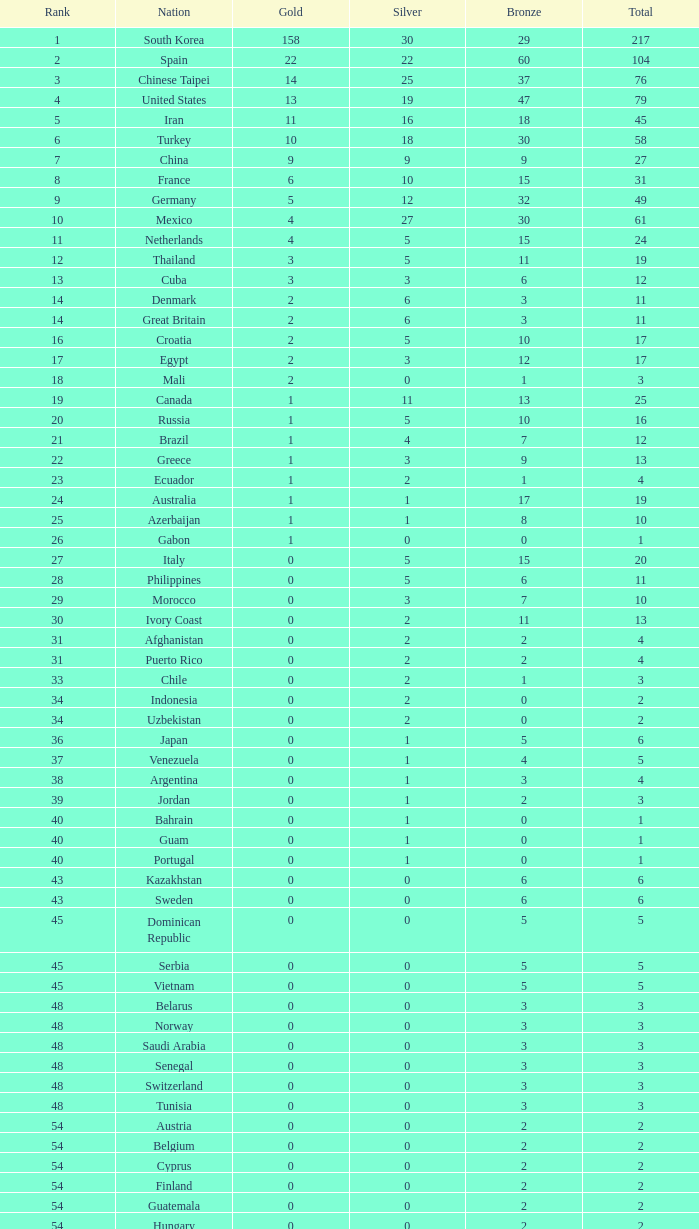Would you mind parsing the complete table? {'header': ['Rank', 'Nation', 'Gold', 'Silver', 'Bronze', 'Total'], 'rows': [['1', 'South Korea', '158', '30', '29', '217'], ['2', 'Spain', '22', '22', '60', '104'], ['3', 'Chinese Taipei', '14', '25', '37', '76'], ['4', 'United States', '13', '19', '47', '79'], ['5', 'Iran', '11', '16', '18', '45'], ['6', 'Turkey', '10', '18', '30', '58'], ['7', 'China', '9', '9', '9', '27'], ['8', 'France', '6', '10', '15', '31'], ['9', 'Germany', '5', '12', '32', '49'], ['10', 'Mexico', '4', '27', '30', '61'], ['11', 'Netherlands', '4', '5', '15', '24'], ['12', 'Thailand', '3', '5', '11', '19'], ['13', 'Cuba', '3', '3', '6', '12'], ['14', 'Denmark', '2', '6', '3', '11'], ['14', 'Great Britain', '2', '6', '3', '11'], ['16', 'Croatia', '2', '5', '10', '17'], ['17', 'Egypt', '2', '3', '12', '17'], ['18', 'Mali', '2', '0', '1', '3'], ['19', 'Canada', '1', '11', '13', '25'], ['20', 'Russia', '1', '5', '10', '16'], ['21', 'Brazil', '1', '4', '7', '12'], ['22', 'Greece', '1', '3', '9', '13'], ['23', 'Ecuador', '1', '2', '1', '4'], ['24', 'Australia', '1', '1', '17', '19'], ['25', 'Azerbaijan', '1', '1', '8', '10'], ['26', 'Gabon', '1', '0', '0', '1'], ['27', 'Italy', '0', '5', '15', '20'], ['28', 'Philippines', '0', '5', '6', '11'], ['29', 'Morocco', '0', '3', '7', '10'], ['30', 'Ivory Coast', '0', '2', '11', '13'], ['31', 'Afghanistan', '0', '2', '2', '4'], ['31', 'Puerto Rico', '0', '2', '2', '4'], ['33', 'Chile', '0', '2', '1', '3'], ['34', 'Indonesia', '0', '2', '0', '2'], ['34', 'Uzbekistan', '0', '2', '0', '2'], ['36', 'Japan', '0', '1', '5', '6'], ['37', 'Venezuela', '0', '1', '4', '5'], ['38', 'Argentina', '0', '1', '3', '4'], ['39', 'Jordan', '0', '1', '2', '3'], ['40', 'Bahrain', '0', '1', '0', '1'], ['40', 'Guam', '0', '1', '0', '1'], ['40', 'Portugal', '0', '1', '0', '1'], ['43', 'Kazakhstan', '0', '0', '6', '6'], ['43', 'Sweden', '0', '0', '6', '6'], ['45', 'Dominican Republic', '0', '0', '5', '5'], ['45', 'Serbia', '0', '0', '5', '5'], ['45', 'Vietnam', '0', '0', '5', '5'], ['48', 'Belarus', '0', '0', '3', '3'], ['48', 'Norway', '0', '0', '3', '3'], ['48', 'Saudi Arabia', '0', '0', '3', '3'], ['48', 'Senegal', '0', '0', '3', '3'], ['48', 'Switzerland', '0', '0', '3', '3'], ['48', 'Tunisia', '0', '0', '3', '3'], ['54', 'Austria', '0', '0', '2', '2'], ['54', 'Belgium', '0', '0', '2', '2'], ['54', 'Cyprus', '0', '0', '2', '2'], ['54', 'Finland', '0', '0', '2', '2'], ['54', 'Guatemala', '0', '0', '2', '2'], ['54', 'Hungary', '0', '0', '2', '2'], ['54', 'Malaysia', '0', '0', '2', '2'], ['54', 'Nepal', '0', '0', '2', '2'], ['54', 'Slovenia', '0', '0', '2', '2'], ['63', 'Colombia', '0', '0', '1', '1'], ['63', 'Costa Rica', '0', '0', '1', '1'], ['63', 'Israel', '0', '0', '1', '1'], ['63', 'Nigeria', '0', '0', '1', '1'], ['63', 'Poland', '0', '0', '1', '1'], ['63', 'Uganda', '0', '0', '1', '1'], ['Total', 'Total', '280', '280', '560', '1120']]} For the nation ranked 33rd with over one bronze, what is the overall medal count? None. 